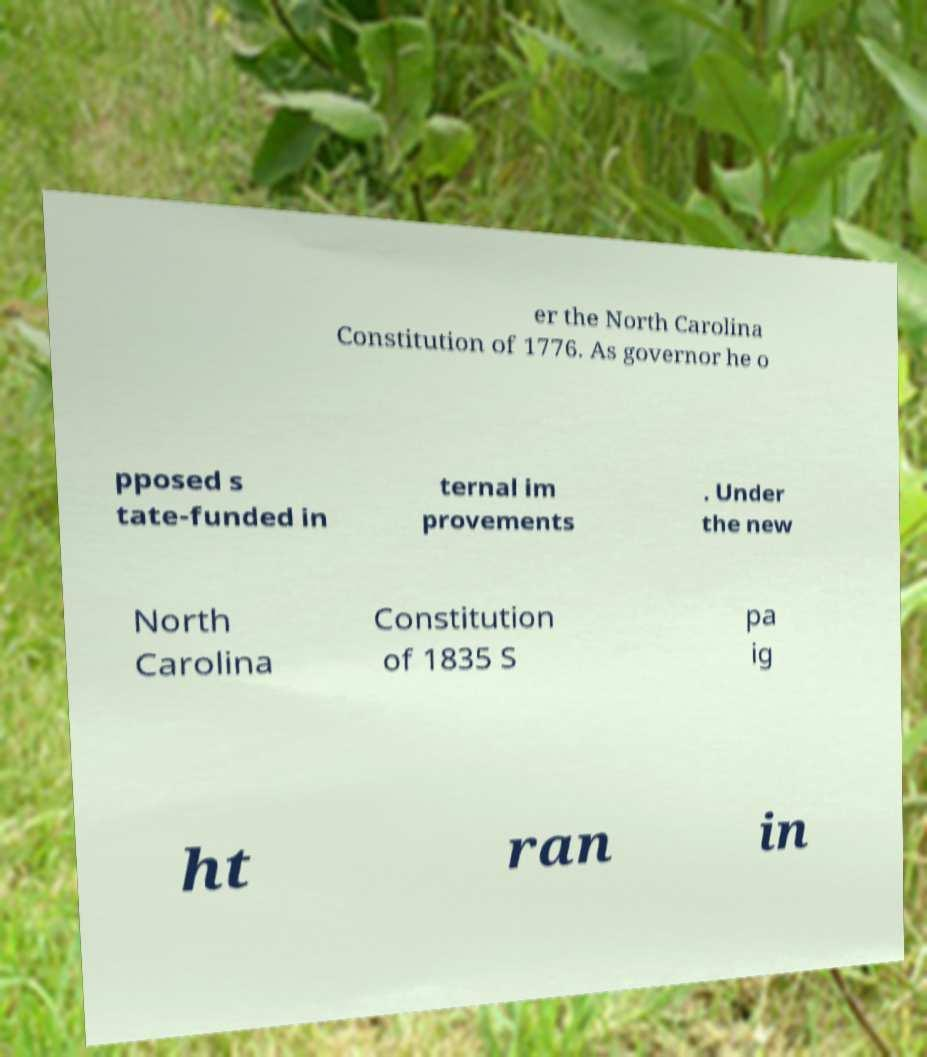Please identify and transcribe the text found in this image. er the North Carolina Constitution of 1776. As governor he o pposed s tate-funded in ternal im provements . Under the new North Carolina Constitution of 1835 S pa ig ht ran in 